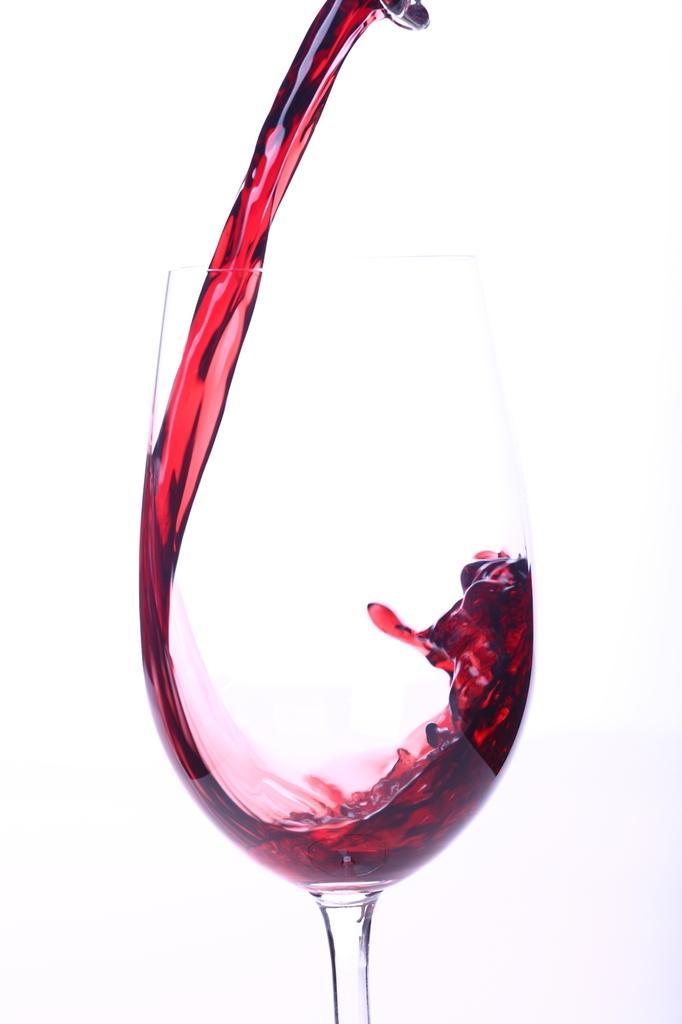In one or two sentences, can you explain what this image depicts? At the top of the image I can see some steel object, from that red wine is pouring in a wine glass. In the back I can see the brightness. 